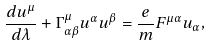Convert formula to latex. <formula><loc_0><loc_0><loc_500><loc_500>\frac { d u ^ { \mu } } { d \lambda } + \Gamma _ { \alpha \beta } ^ { \mu } u ^ { \alpha } u ^ { \beta } = \frac { e } { m } F ^ { \mu \alpha } u _ { \alpha } ,</formula> 